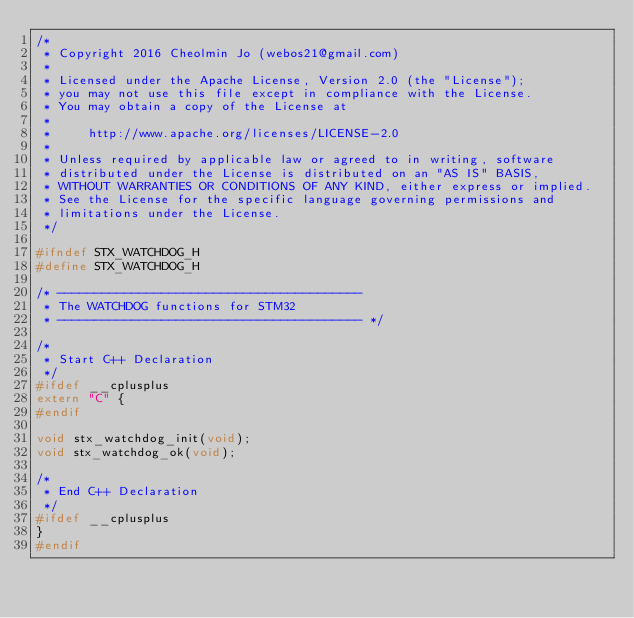<code> <loc_0><loc_0><loc_500><loc_500><_C_>/*
 * Copyright 2016 Cheolmin Jo (webos21@gmail.com)
 *
 * Licensed under the Apache License, Version 2.0 (the "License");
 * you may not use this file except in compliance with the License.
 * You may obtain a copy of the License at
 *
 *     http://www.apache.org/licenses/LICENSE-2.0
 *
 * Unless required by applicable law or agreed to in writing, software
 * distributed under the License is distributed on an "AS IS" BASIS,
 * WITHOUT WARRANTIES OR CONDITIONS OF ANY KIND, either express or implied.
 * See the License for the specific language governing permissions and
 * limitations under the License.
 */

#ifndef STX_WATCHDOG_H
#define STX_WATCHDOG_H

/* -----------------------------------------
 * The WATCHDOG functions for STM32
 * ----------------------------------------- */

/*
 * Start C++ Declaration
 */
#ifdef __cplusplus
extern "C" {
#endif

void stx_watchdog_init(void);
void stx_watchdog_ok(void);

/*
 * End C++ Declaration
 */
#ifdef __cplusplus
}
#endif
</code> 